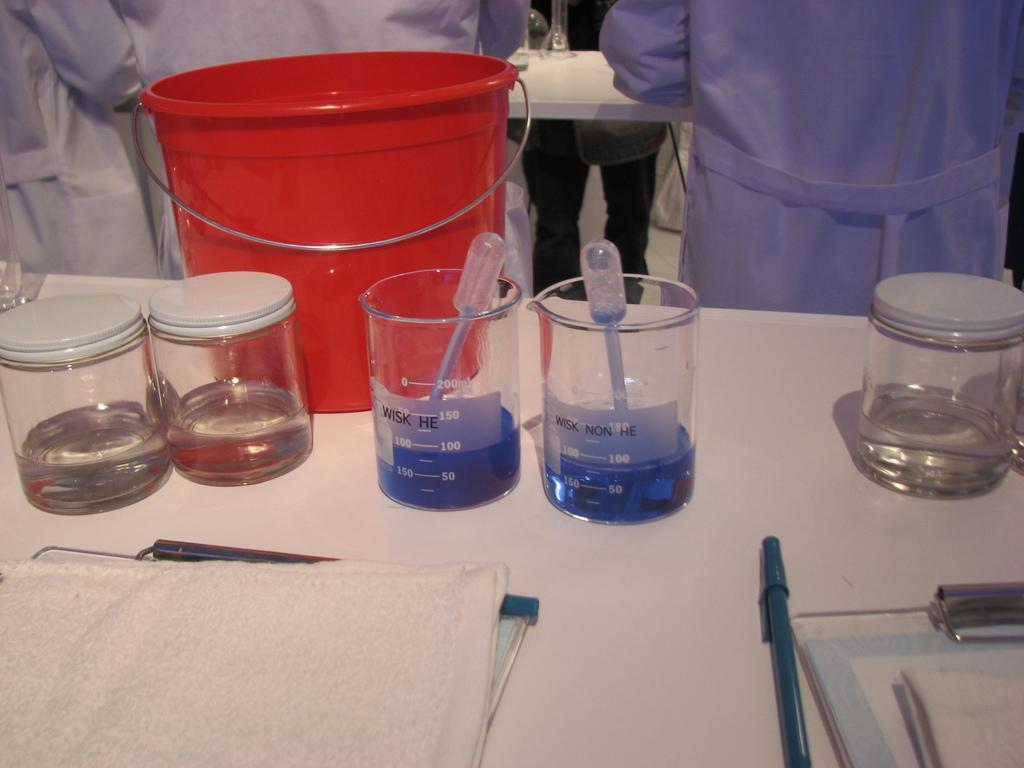Could you give a brief overview of what you see in this image? In this image we can see the persons standing. And we can see the table, on the table there are bottles with water and beakers with liquid. And we can see the bucket, cloth, pad, pen and few objects. 